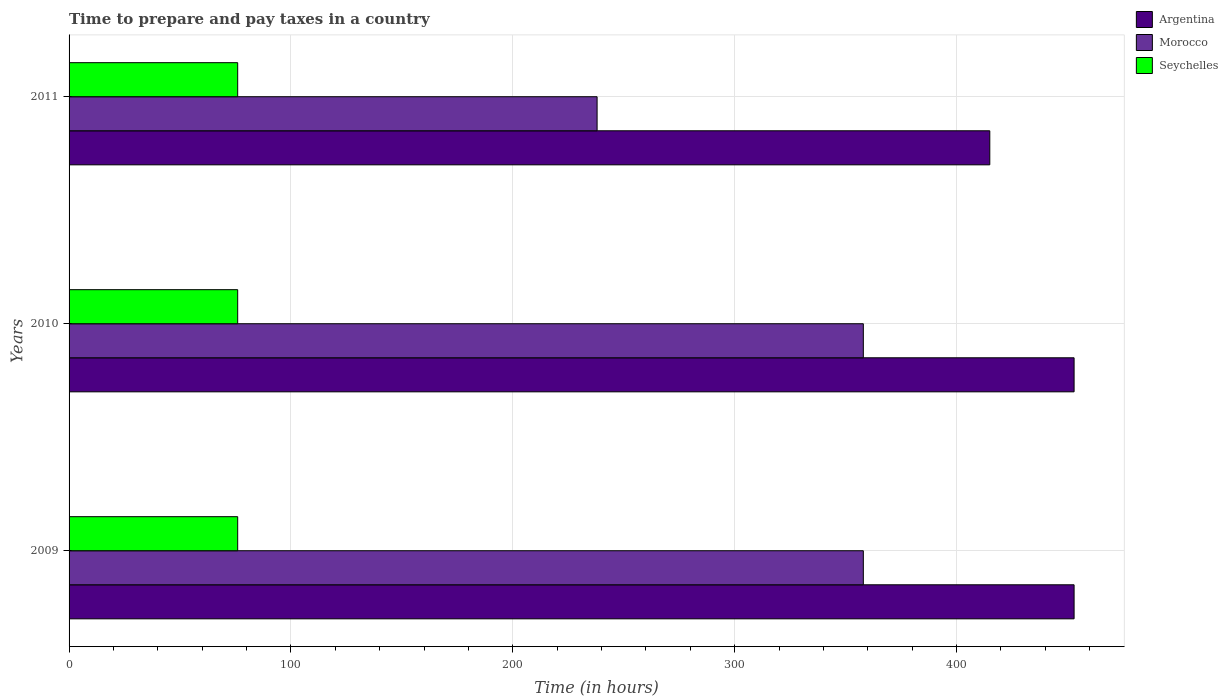How many different coloured bars are there?
Provide a short and direct response. 3. Are the number of bars on each tick of the Y-axis equal?
Your response must be concise. Yes. How many bars are there on the 1st tick from the bottom?
Ensure brevity in your answer.  3. What is the number of hours required to prepare and pay taxes in Argentina in 2009?
Ensure brevity in your answer.  453. Across all years, what is the maximum number of hours required to prepare and pay taxes in Argentina?
Your answer should be compact. 453. Across all years, what is the minimum number of hours required to prepare and pay taxes in Morocco?
Ensure brevity in your answer.  238. What is the total number of hours required to prepare and pay taxes in Seychelles in the graph?
Keep it short and to the point. 228. What is the difference between the number of hours required to prepare and pay taxes in Seychelles in 2010 and the number of hours required to prepare and pay taxes in Morocco in 2009?
Offer a terse response. -282. What is the average number of hours required to prepare and pay taxes in Argentina per year?
Your answer should be compact. 440.33. In the year 2010, what is the difference between the number of hours required to prepare and pay taxes in Morocco and number of hours required to prepare and pay taxes in Seychelles?
Provide a short and direct response. 282. What is the ratio of the number of hours required to prepare and pay taxes in Morocco in 2009 to that in 2010?
Ensure brevity in your answer.  1. Is the difference between the number of hours required to prepare and pay taxes in Morocco in 2009 and 2010 greater than the difference between the number of hours required to prepare and pay taxes in Seychelles in 2009 and 2010?
Keep it short and to the point. No. What is the difference between the highest and the second highest number of hours required to prepare and pay taxes in Morocco?
Your answer should be compact. 0. What is the difference between the highest and the lowest number of hours required to prepare and pay taxes in Morocco?
Ensure brevity in your answer.  120. What does the 1st bar from the top in 2010 represents?
Offer a very short reply. Seychelles. What does the 2nd bar from the bottom in 2010 represents?
Your answer should be compact. Morocco. Is it the case that in every year, the sum of the number of hours required to prepare and pay taxes in Argentina and number of hours required to prepare and pay taxes in Morocco is greater than the number of hours required to prepare and pay taxes in Seychelles?
Give a very brief answer. Yes. How many years are there in the graph?
Your answer should be compact. 3. Does the graph contain grids?
Your response must be concise. Yes. How many legend labels are there?
Your response must be concise. 3. What is the title of the graph?
Your response must be concise. Time to prepare and pay taxes in a country. What is the label or title of the X-axis?
Provide a succinct answer. Time (in hours). What is the label or title of the Y-axis?
Make the answer very short. Years. What is the Time (in hours) of Argentina in 2009?
Keep it short and to the point. 453. What is the Time (in hours) in Morocco in 2009?
Your response must be concise. 358. What is the Time (in hours) of Argentina in 2010?
Offer a very short reply. 453. What is the Time (in hours) in Morocco in 2010?
Your answer should be compact. 358. What is the Time (in hours) of Seychelles in 2010?
Provide a succinct answer. 76. What is the Time (in hours) of Argentina in 2011?
Your response must be concise. 415. What is the Time (in hours) of Morocco in 2011?
Your response must be concise. 238. What is the Time (in hours) in Seychelles in 2011?
Keep it short and to the point. 76. Across all years, what is the maximum Time (in hours) of Argentina?
Your answer should be very brief. 453. Across all years, what is the maximum Time (in hours) of Morocco?
Ensure brevity in your answer.  358. Across all years, what is the minimum Time (in hours) in Argentina?
Ensure brevity in your answer.  415. Across all years, what is the minimum Time (in hours) of Morocco?
Give a very brief answer. 238. Across all years, what is the minimum Time (in hours) in Seychelles?
Ensure brevity in your answer.  76. What is the total Time (in hours) in Argentina in the graph?
Give a very brief answer. 1321. What is the total Time (in hours) of Morocco in the graph?
Ensure brevity in your answer.  954. What is the total Time (in hours) of Seychelles in the graph?
Your answer should be very brief. 228. What is the difference between the Time (in hours) of Seychelles in 2009 and that in 2010?
Keep it short and to the point. 0. What is the difference between the Time (in hours) in Argentina in 2009 and that in 2011?
Keep it short and to the point. 38. What is the difference between the Time (in hours) of Morocco in 2009 and that in 2011?
Provide a succinct answer. 120. What is the difference between the Time (in hours) of Seychelles in 2009 and that in 2011?
Ensure brevity in your answer.  0. What is the difference between the Time (in hours) of Morocco in 2010 and that in 2011?
Provide a short and direct response. 120. What is the difference between the Time (in hours) in Seychelles in 2010 and that in 2011?
Make the answer very short. 0. What is the difference between the Time (in hours) in Argentina in 2009 and the Time (in hours) in Seychelles in 2010?
Your response must be concise. 377. What is the difference between the Time (in hours) of Morocco in 2009 and the Time (in hours) of Seychelles in 2010?
Provide a succinct answer. 282. What is the difference between the Time (in hours) of Argentina in 2009 and the Time (in hours) of Morocco in 2011?
Provide a succinct answer. 215. What is the difference between the Time (in hours) in Argentina in 2009 and the Time (in hours) in Seychelles in 2011?
Make the answer very short. 377. What is the difference between the Time (in hours) in Morocco in 2009 and the Time (in hours) in Seychelles in 2011?
Offer a terse response. 282. What is the difference between the Time (in hours) in Argentina in 2010 and the Time (in hours) in Morocco in 2011?
Your response must be concise. 215. What is the difference between the Time (in hours) in Argentina in 2010 and the Time (in hours) in Seychelles in 2011?
Make the answer very short. 377. What is the difference between the Time (in hours) in Morocco in 2010 and the Time (in hours) in Seychelles in 2011?
Provide a short and direct response. 282. What is the average Time (in hours) of Argentina per year?
Offer a terse response. 440.33. What is the average Time (in hours) of Morocco per year?
Ensure brevity in your answer.  318. In the year 2009, what is the difference between the Time (in hours) in Argentina and Time (in hours) in Morocco?
Your answer should be very brief. 95. In the year 2009, what is the difference between the Time (in hours) of Argentina and Time (in hours) of Seychelles?
Ensure brevity in your answer.  377. In the year 2009, what is the difference between the Time (in hours) in Morocco and Time (in hours) in Seychelles?
Give a very brief answer. 282. In the year 2010, what is the difference between the Time (in hours) in Argentina and Time (in hours) in Morocco?
Provide a succinct answer. 95. In the year 2010, what is the difference between the Time (in hours) in Argentina and Time (in hours) in Seychelles?
Provide a short and direct response. 377. In the year 2010, what is the difference between the Time (in hours) in Morocco and Time (in hours) in Seychelles?
Ensure brevity in your answer.  282. In the year 2011, what is the difference between the Time (in hours) in Argentina and Time (in hours) in Morocco?
Your response must be concise. 177. In the year 2011, what is the difference between the Time (in hours) of Argentina and Time (in hours) of Seychelles?
Your answer should be compact. 339. In the year 2011, what is the difference between the Time (in hours) in Morocco and Time (in hours) in Seychelles?
Your answer should be very brief. 162. What is the ratio of the Time (in hours) of Argentina in 2009 to that in 2011?
Keep it short and to the point. 1.09. What is the ratio of the Time (in hours) of Morocco in 2009 to that in 2011?
Ensure brevity in your answer.  1.5. What is the ratio of the Time (in hours) in Argentina in 2010 to that in 2011?
Your response must be concise. 1.09. What is the ratio of the Time (in hours) in Morocco in 2010 to that in 2011?
Keep it short and to the point. 1.5. What is the difference between the highest and the second highest Time (in hours) in Argentina?
Make the answer very short. 0. What is the difference between the highest and the lowest Time (in hours) in Argentina?
Offer a terse response. 38. What is the difference between the highest and the lowest Time (in hours) of Morocco?
Make the answer very short. 120. 